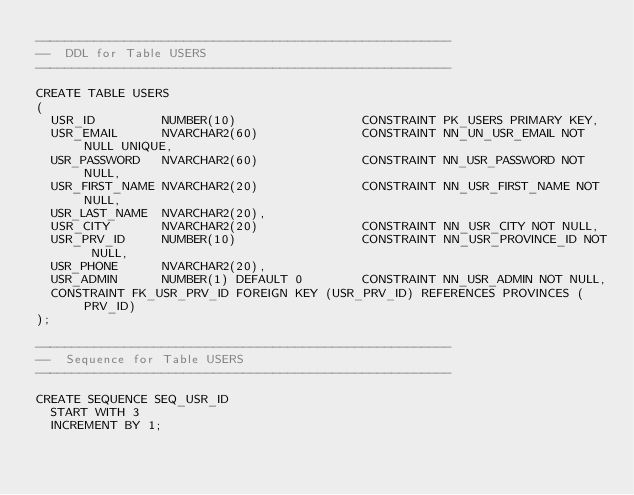<code> <loc_0><loc_0><loc_500><loc_500><_SQL_>--------------------------------------------------------
--  DDL for Table USERS
--------------------------------------------------------

CREATE TABLE USERS
(
  USR_ID         NUMBER(10)                 CONSTRAINT PK_USERS PRIMARY KEY,
  USR_EMAIL      NVARCHAR2(60)              CONSTRAINT NN_UN_USR_EMAIL NOT NULL UNIQUE,
  USR_PASSWORD   NVARCHAR2(60)              CONSTRAINT NN_USR_PASSWORD NOT NULL,
  USR_FIRST_NAME NVARCHAR2(20)              CONSTRAINT NN_USR_FIRST_NAME NOT NULL,
  USR_LAST_NAME  NVARCHAR2(20),
  USR_CITY       NVARCHAR2(20)              CONSTRAINT NN_USR_CITY NOT NULL,
  USR_PRV_ID     NUMBER(10)                 CONSTRAINT NN_USR_PROVINCE_ID NOT NULL,
  USR_PHONE      NVARCHAR2(20),
  USR_ADMIN      NUMBER(1) DEFAULT 0        CONSTRAINT NN_USR_ADMIN NOT NULL,
  CONSTRAINT FK_USR_PRV_ID FOREIGN KEY (USR_PRV_ID) REFERENCES PROVINCES (PRV_ID)
);

--------------------------------------------------------
--  Sequence for Table USERS
--------------------------------------------------------

CREATE SEQUENCE SEQ_USR_ID
  START WITH 3
  INCREMENT BY 1;
</code> 